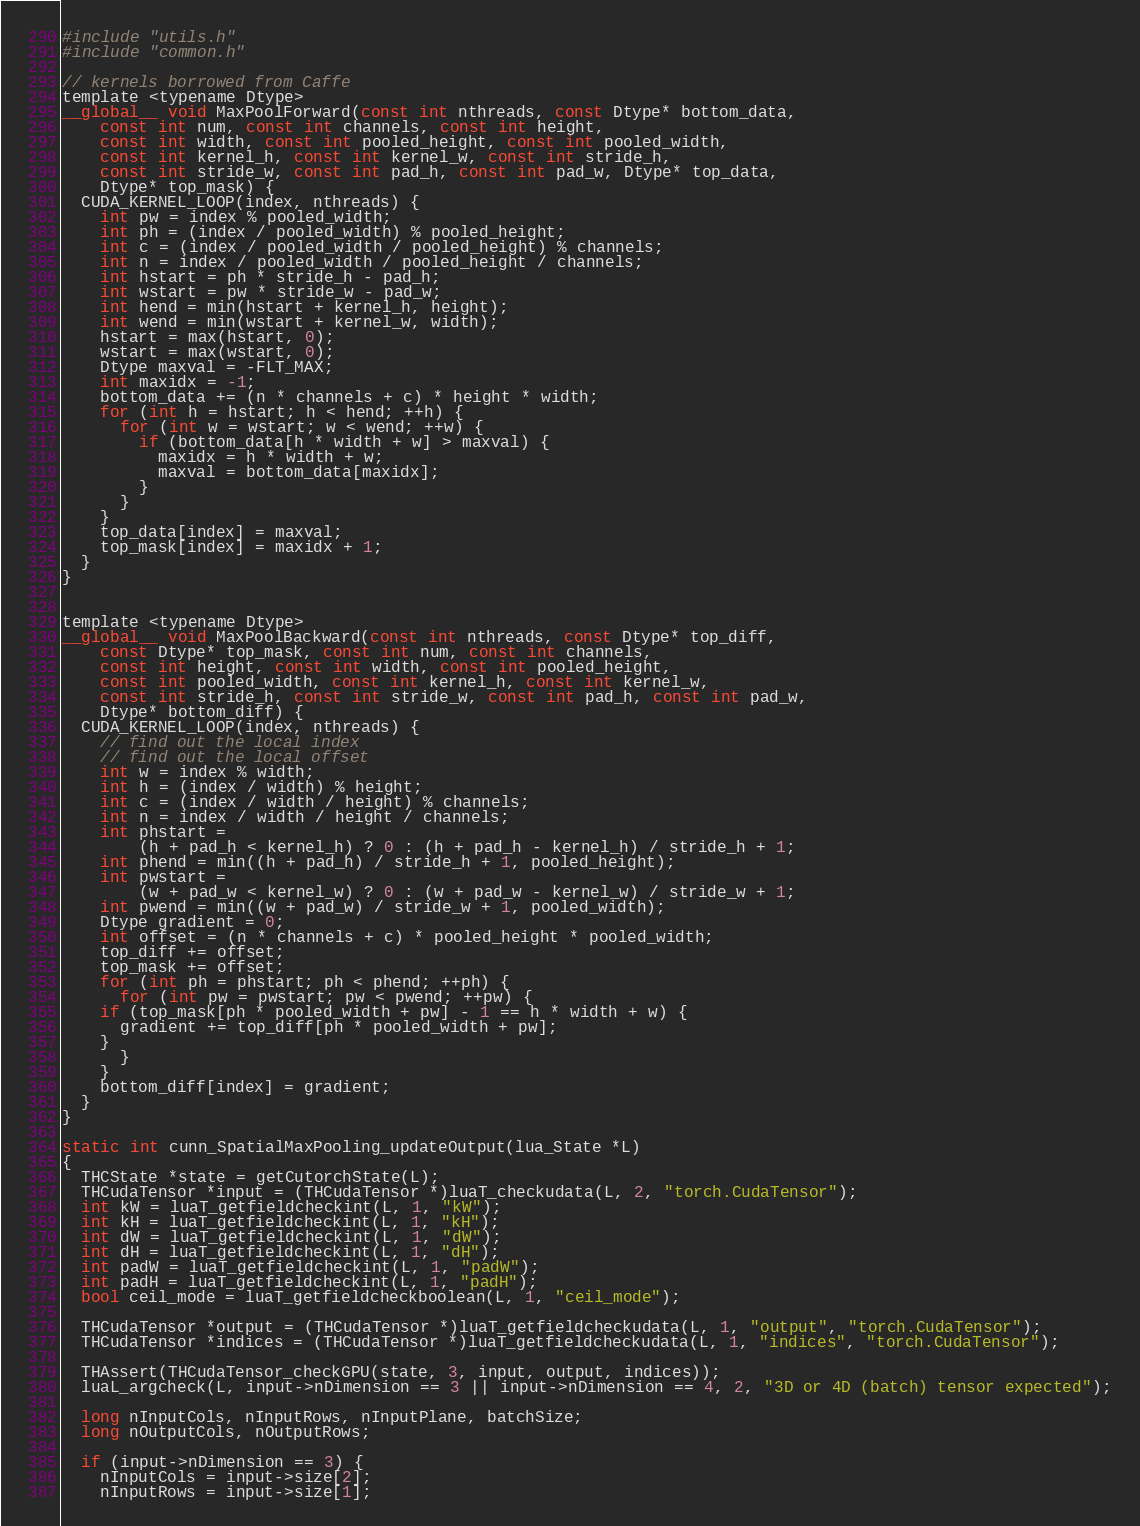<code> <loc_0><loc_0><loc_500><loc_500><_Cuda_>#include "utils.h"
#include "common.h"

// kernels borrowed from Caffe
template <typename Dtype>
__global__ void MaxPoolForward(const int nthreads, const Dtype* bottom_data,
    const int num, const int channels, const int height,
    const int width, const int pooled_height, const int pooled_width,
    const int kernel_h, const int kernel_w, const int stride_h,
    const int stride_w, const int pad_h, const int pad_w, Dtype* top_data,
    Dtype* top_mask) {
  CUDA_KERNEL_LOOP(index, nthreads) {
    int pw = index % pooled_width;
    int ph = (index / pooled_width) % pooled_height;
    int c = (index / pooled_width / pooled_height) % channels;
    int n = index / pooled_width / pooled_height / channels;
    int hstart = ph * stride_h - pad_h;
    int wstart = pw * stride_w - pad_w;
    int hend = min(hstart + kernel_h, height);
    int wend = min(wstart + kernel_w, width);
    hstart = max(hstart, 0);
    wstart = max(wstart, 0);
    Dtype maxval = -FLT_MAX;
    int maxidx = -1;
    bottom_data += (n * channels + c) * height * width;
    for (int h = hstart; h < hend; ++h) {
      for (int w = wstart; w < wend; ++w) {
        if (bottom_data[h * width + w] > maxval) {
          maxidx = h * width + w;
          maxval = bottom_data[maxidx];
        }
      }
    }
    top_data[index] = maxval;
    top_mask[index] = maxidx + 1;
  }
}


template <typename Dtype>
__global__ void MaxPoolBackward(const int nthreads, const Dtype* top_diff,
    const Dtype* top_mask, const int num, const int channels,
    const int height, const int width, const int pooled_height,
    const int pooled_width, const int kernel_h, const int kernel_w,
    const int stride_h, const int stride_w, const int pad_h, const int pad_w,
    Dtype* bottom_diff) {
  CUDA_KERNEL_LOOP(index, nthreads) {
    // find out the local index
    // find out the local offset
    int w = index % width;
    int h = (index / width) % height;
    int c = (index / width / height) % channels;
    int n = index / width / height / channels;
    int phstart =
        (h + pad_h < kernel_h) ? 0 : (h + pad_h - kernel_h) / stride_h + 1;
    int phend = min((h + pad_h) / stride_h + 1, pooled_height);
    int pwstart =
        (w + pad_w < kernel_w) ? 0 : (w + pad_w - kernel_w) / stride_w + 1;
    int pwend = min((w + pad_w) / stride_w + 1, pooled_width);
    Dtype gradient = 0;
    int offset = (n * channels + c) * pooled_height * pooled_width;
    top_diff += offset;
    top_mask += offset;
    for (int ph = phstart; ph < phend; ++ph) {
      for (int pw = pwstart; pw < pwend; ++pw) {
	if (top_mask[ph * pooled_width + pw] - 1 == h * width + w) {
	  gradient += top_diff[ph * pooled_width + pw];
	}
      }
    }
    bottom_diff[index] = gradient;
  }
}

static int cunn_SpatialMaxPooling_updateOutput(lua_State *L)
{
  THCState *state = getCutorchState(L);
  THCudaTensor *input = (THCudaTensor *)luaT_checkudata(L, 2, "torch.CudaTensor");
  int kW = luaT_getfieldcheckint(L, 1, "kW");
  int kH = luaT_getfieldcheckint(L, 1, "kH");
  int dW = luaT_getfieldcheckint(L, 1, "dW");
  int dH = luaT_getfieldcheckint(L, 1, "dH");
  int padW = luaT_getfieldcheckint(L, 1, "padW");
  int padH = luaT_getfieldcheckint(L, 1, "padH");
  bool ceil_mode = luaT_getfieldcheckboolean(L, 1, "ceil_mode");

  THCudaTensor *output = (THCudaTensor *)luaT_getfieldcheckudata(L, 1, "output", "torch.CudaTensor");
  THCudaTensor *indices = (THCudaTensor *)luaT_getfieldcheckudata(L, 1, "indices", "torch.CudaTensor");

  THAssert(THCudaTensor_checkGPU(state, 3, input, output, indices));
  luaL_argcheck(L, input->nDimension == 3 || input->nDimension == 4, 2, "3D or 4D (batch) tensor expected");

  long nInputCols, nInputRows, nInputPlane, batchSize;
  long nOutputCols, nOutputRows;

  if (input->nDimension == 3) {
    nInputCols = input->size[2];
    nInputRows = input->size[1];</code> 